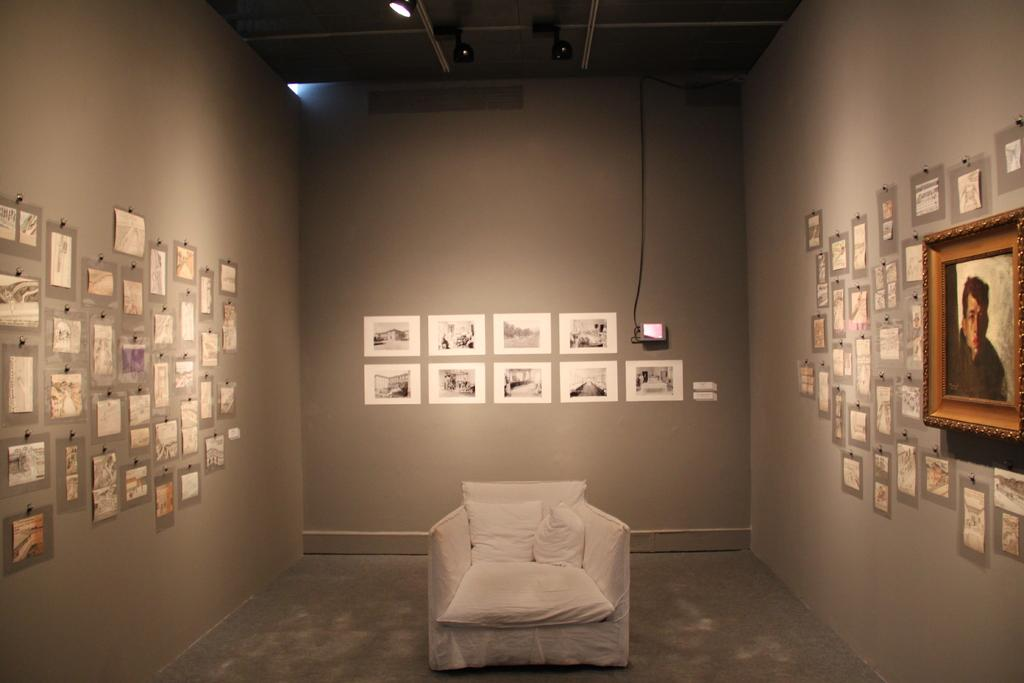What is hanging on the wall in the image? There are pictures on the wall. What can be seen on the chair in the image? There are pillows on a chair. Can you describe the light source in the image? There is a focusing light on top of something. What type of leather material is used for the chair in the image? There is no mention of leather in the image, and the material of the chair is not specified. How does the focusing light kick off the event in the image? There is no event depicted in the image, and the focusing light is not associated with any action or activity. 